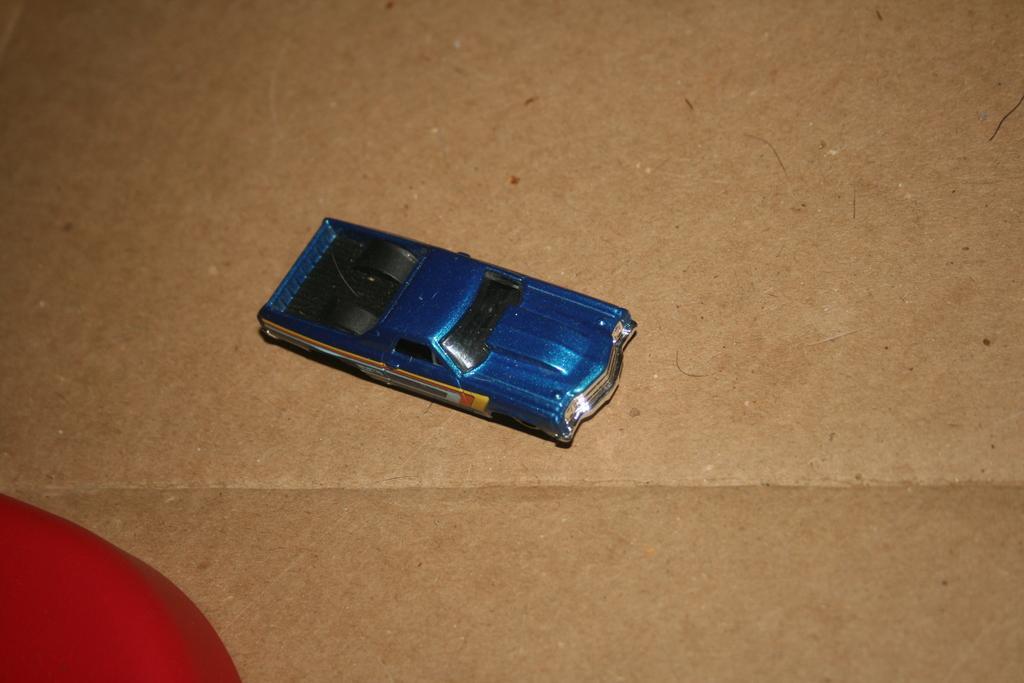Describe this image in one or two sentences. In the image there is a toy car kept on the floor and beside the car there is some red color object. 